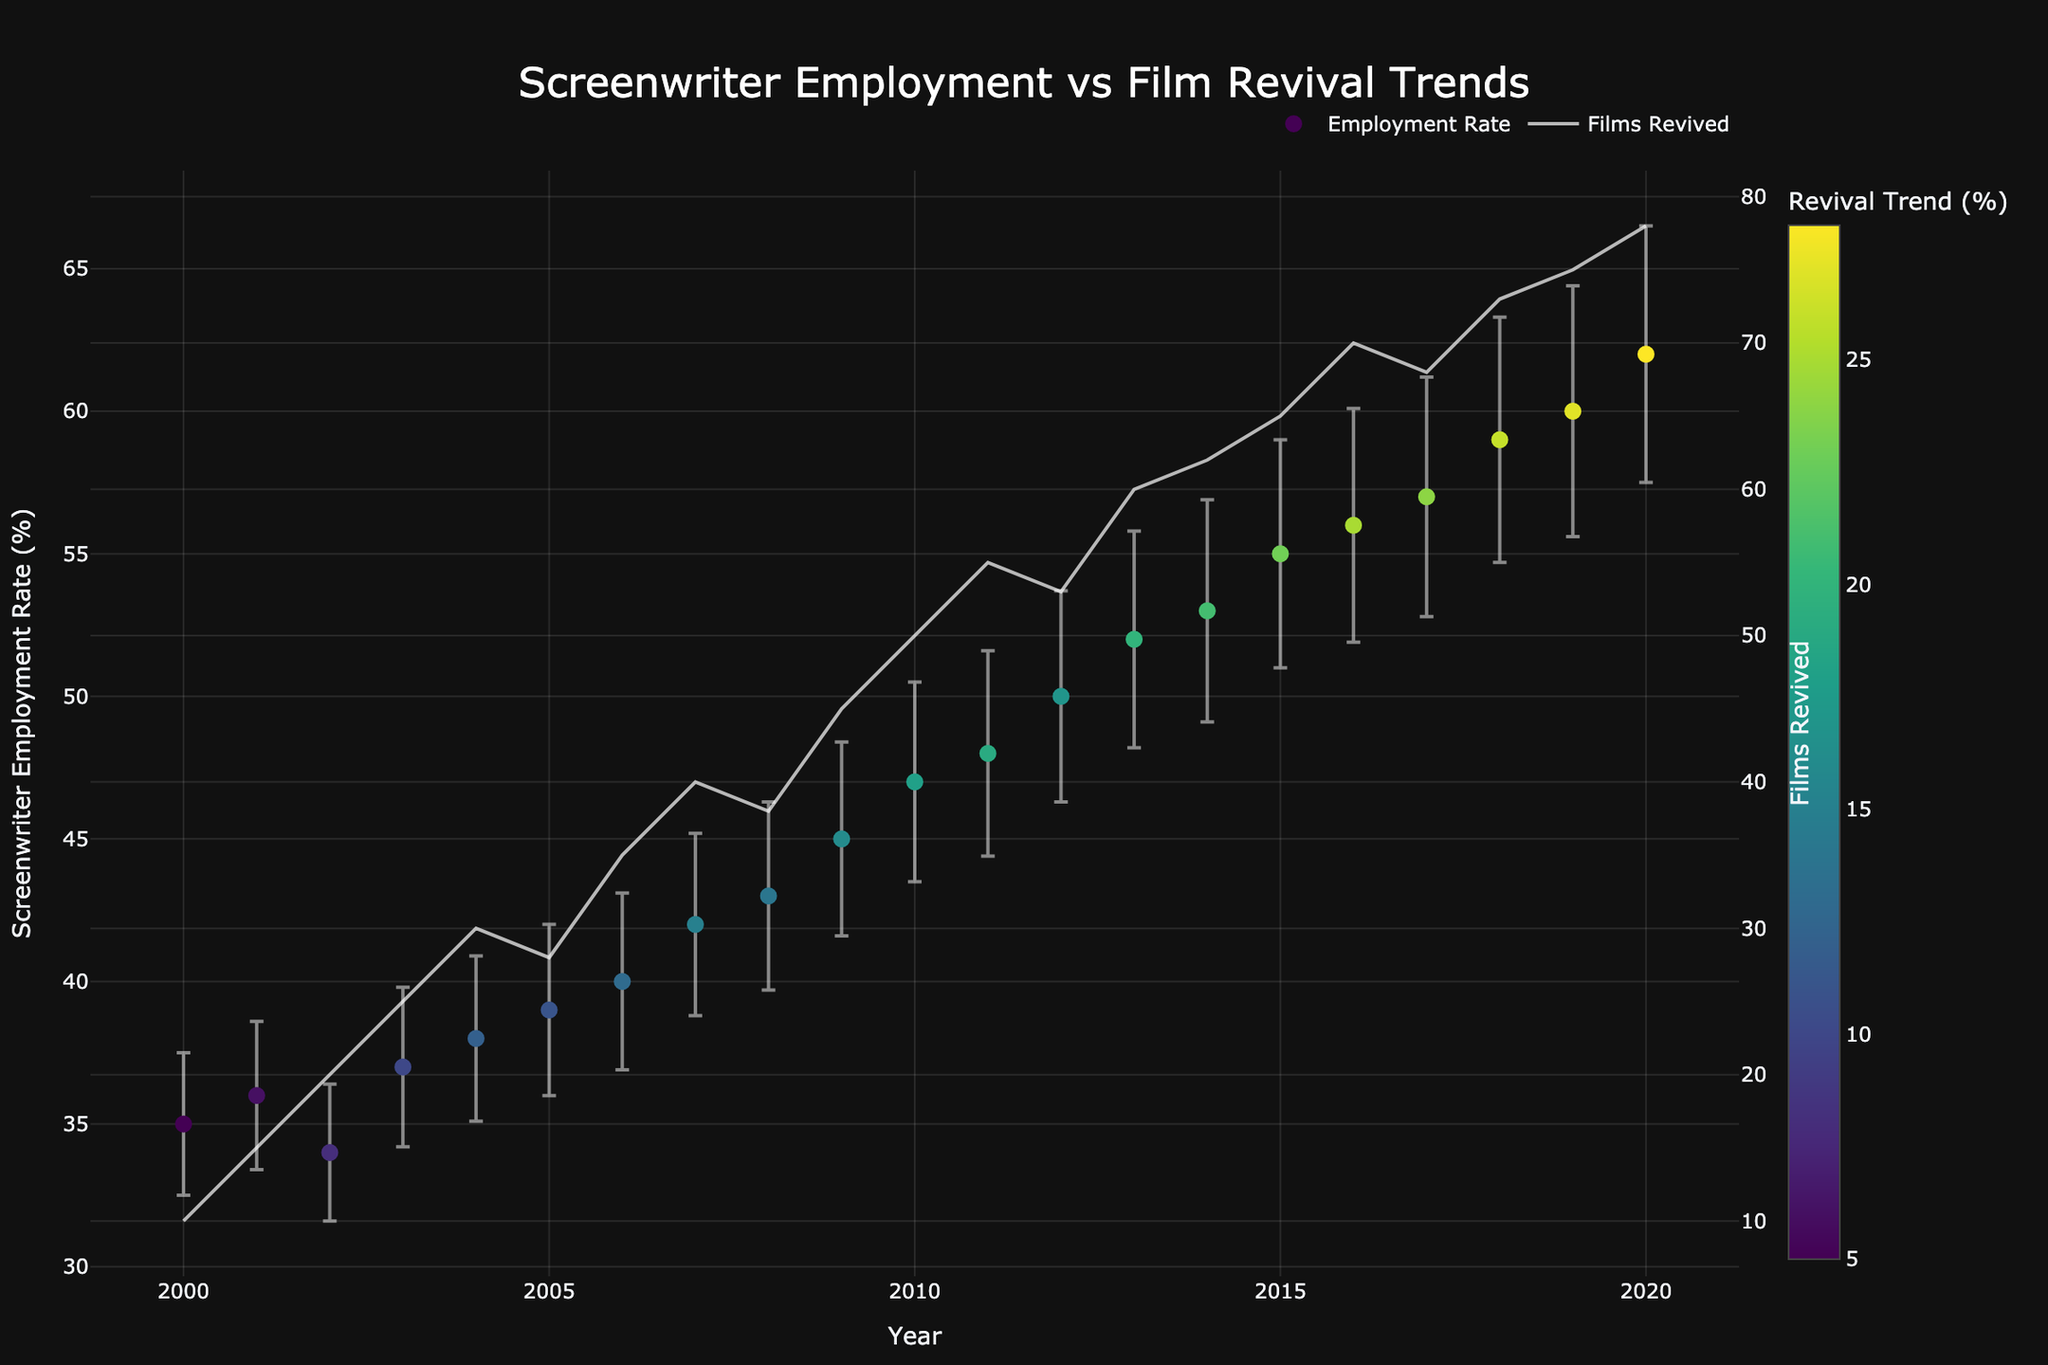What is the title of the plot? The title of a plot is usually displayed prominently at the top of the figure. In this case, the title text is "Screenwriter Employment vs Film Revival Trends".
Answer: Screenwriter Employment vs Film Revival Trends What are the axes labels of the plot? Axes labels are typically found along the x-axis and y-axis. Here, the x-axis label is "Year" and the primary y-axis label is "Screenwriter Employment Rate (%)". Additionally, the secondary y-axis on the right side is labeled "Films Revived".
Answer: Year; Screenwriter Employment Rate (%); Films Revived What was the Screenwriter Employment Rate (%) error in 2010? Errors are presented as vertical error bars in the plot. In 2010, the Screenwriter Employment Rate had an error of 3.5% as displayed by the length of the error bar above and below the marker for that year.
Answer: 3.5% In which year did the Screenwriter Employment Rate reach 60%? You can identify this by locating the year on the x-axis where the Screenwriter Employment Rate (%) marker reaches 60%. According to the data points, it happened in 2019.
Answer: 2019 How many films were revived in 2016 and how does that compare to 2018? Locate the data points on the secondary (right) y-axis for the years 2016 and 2018. In 2016, 70 films were revived, while in 2018, 73 films were revived. This shows an increase of 3 films revived in 2018 compared to 2016.
Answer: 70 in 2016 and 73 in 2018; 3 more films revived in 2018 What trend can be seen in the Screenwriter Employment Rate from 2000 to 2020? Observe the markers on the primary y-axis from 2000 to 2020. There is a clear upward trend in the Screenwriter Employment Rate, which starts at 35% in 2000 and rises progressively to 62% in 2020, showing continuous growth over the period.
Answer: Upward trend Which year experienced the highest revival trend percentage and what was the Screenwriter Employment Rate that year? Look for the marker with the highest color intensity (since the color scale indicates the Revival Trend (%)). The year 2020 had the highest revival trend at 28%, with a Screenwriter Employment Rate of 62%.
Answer: 2020; 62% What is the range of Screenwriter Employment Rates over the years? Identify the minimum and maximum Screenwriter Employment Rate from the plot. The lowest rate is 34% in 2002, and the highest is 62% in 2020. The range is calculated as 62% - 34% = 28%.
Answer: 28% 